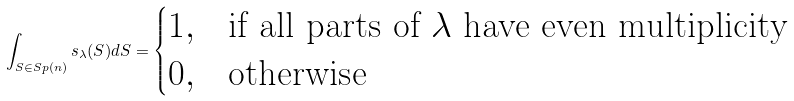<formula> <loc_0><loc_0><loc_500><loc_500>\int _ { S \in S p ( n ) } s _ { \lambda } ( S ) d S = \begin{cases} 1 , & \text {if all parts of $\lambda$ have even multiplicity} \\ 0 , & \text {otherwise} \end{cases}</formula> 